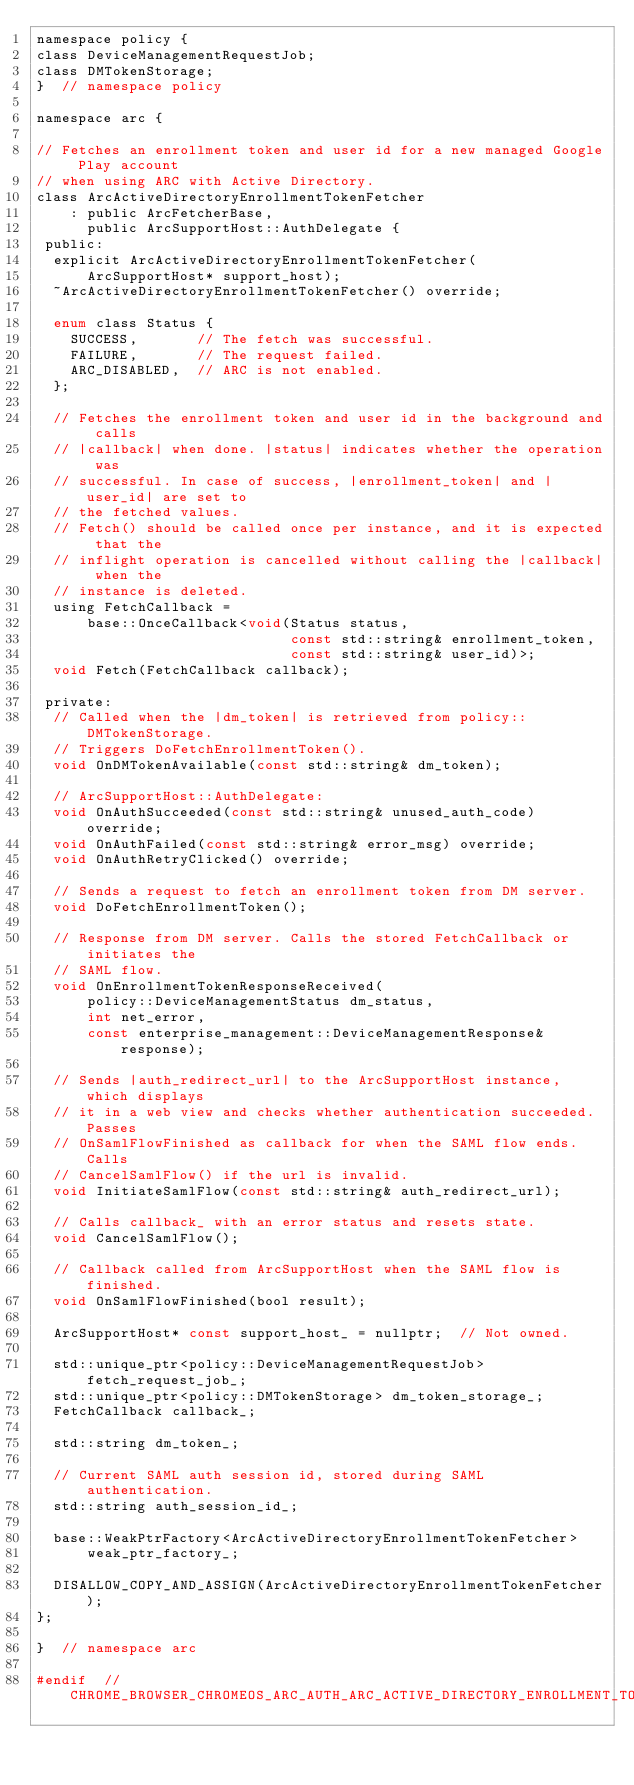<code> <loc_0><loc_0><loc_500><loc_500><_C_>namespace policy {
class DeviceManagementRequestJob;
class DMTokenStorage;
}  // namespace policy

namespace arc {

// Fetches an enrollment token and user id for a new managed Google Play account
// when using ARC with Active Directory.
class ArcActiveDirectoryEnrollmentTokenFetcher
    : public ArcFetcherBase,
      public ArcSupportHost::AuthDelegate {
 public:
  explicit ArcActiveDirectoryEnrollmentTokenFetcher(
      ArcSupportHost* support_host);
  ~ArcActiveDirectoryEnrollmentTokenFetcher() override;

  enum class Status {
    SUCCESS,       // The fetch was successful.
    FAILURE,       // The request failed.
    ARC_DISABLED,  // ARC is not enabled.
  };

  // Fetches the enrollment token and user id in the background and calls
  // |callback| when done. |status| indicates whether the operation was
  // successful. In case of success, |enrollment_token| and |user_id| are set to
  // the fetched values.
  // Fetch() should be called once per instance, and it is expected that the
  // inflight operation is cancelled without calling the |callback| when the
  // instance is deleted.
  using FetchCallback =
      base::OnceCallback<void(Status status,
                              const std::string& enrollment_token,
                              const std::string& user_id)>;
  void Fetch(FetchCallback callback);

 private:
  // Called when the |dm_token| is retrieved from policy::DMTokenStorage.
  // Triggers DoFetchEnrollmentToken().
  void OnDMTokenAvailable(const std::string& dm_token);

  // ArcSupportHost::AuthDelegate:
  void OnAuthSucceeded(const std::string& unused_auth_code) override;
  void OnAuthFailed(const std::string& error_msg) override;
  void OnAuthRetryClicked() override;

  // Sends a request to fetch an enrollment token from DM server.
  void DoFetchEnrollmentToken();

  // Response from DM server. Calls the stored FetchCallback or initiates the
  // SAML flow.
  void OnEnrollmentTokenResponseReceived(
      policy::DeviceManagementStatus dm_status,
      int net_error,
      const enterprise_management::DeviceManagementResponse& response);

  // Sends |auth_redirect_url| to the ArcSupportHost instance, which displays
  // it in a web view and checks whether authentication succeeded. Passes
  // OnSamlFlowFinished as callback for when the SAML flow ends. Calls
  // CancelSamlFlow() if the url is invalid.
  void InitiateSamlFlow(const std::string& auth_redirect_url);

  // Calls callback_ with an error status and resets state.
  void CancelSamlFlow();

  // Callback called from ArcSupportHost when the SAML flow is finished.
  void OnSamlFlowFinished(bool result);

  ArcSupportHost* const support_host_ = nullptr;  // Not owned.

  std::unique_ptr<policy::DeviceManagementRequestJob> fetch_request_job_;
  std::unique_ptr<policy::DMTokenStorage> dm_token_storage_;
  FetchCallback callback_;

  std::string dm_token_;

  // Current SAML auth session id, stored during SAML authentication.
  std::string auth_session_id_;

  base::WeakPtrFactory<ArcActiveDirectoryEnrollmentTokenFetcher>
      weak_ptr_factory_;

  DISALLOW_COPY_AND_ASSIGN(ArcActiveDirectoryEnrollmentTokenFetcher);
};

}  // namespace arc

#endif  // CHROME_BROWSER_CHROMEOS_ARC_AUTH_ARC_ACTIVE_DIRECTORY_ENROLLMENT_TOKEN_FETCHER_H_
</code> 